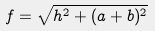<formula> <loc_0><loc_0><loc_500><loc_500>f = \sqrt { h ^ { 2 } + ( a + b ) ^ { 2 } }</formula> 